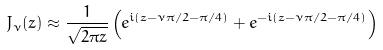<formula> <loc_0><loc_0><loc_500><loc_500>J _ { \nu } ( z ) \approx \frac { 1 } { \sqrt { 2 \pi z } } \left ( e ^ { i ( z - \nu \pi / 2 - \pi / 4 ) } + e ^ { - i ( z - \nu \pi / 2 - \pi / 4 ) } \right )</formula> 